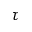<formula> <loc_0><loc_0><loc_500><loc_500>\tau</formula> 